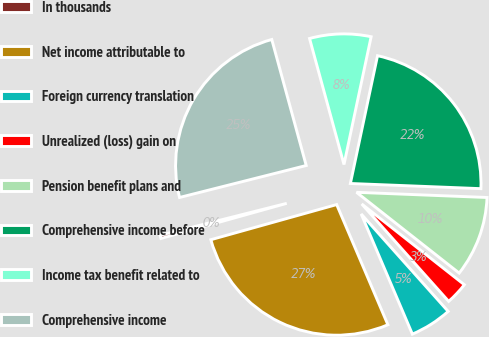<chart> <loc_0><loc_0><loc_500><loc_500><pie_chart><fcel>In thousands<fcel>Net income attributable to<fcel>Foreign currency translation<fcel>Unrealized (loss) gain on<fcel>Pension benefit plans and<fcel>Comprehensive income before<fcel>Income tax benefit related to<fcel>Comprehensive income<nl><fcel>0.4%<fcel>27.08%<fcel>5.19%<fcel>2.79%<fcel>9.98%<fcel>22.3%<fcel>7.58%<fcel>24.69%<nl></chart> 